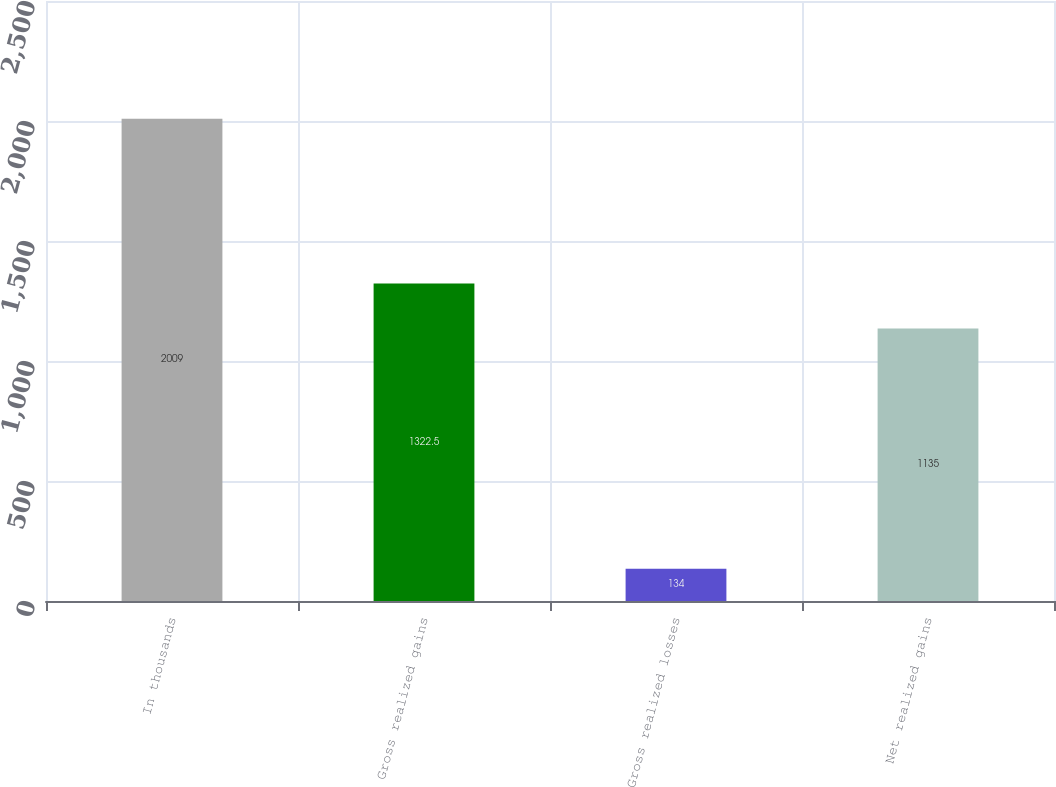Convert chart to OTSL. <chart><loc_0><loc_0><loc_500><loc_500><bar_chart><fcel>In thousands<fcel>Gross realized gains<fcel>Gross realized losses<fcel>Net realized gains<nl><fcel>2009<fcel>1322.5<fcel>134<fcel>1135<nl></chart> 